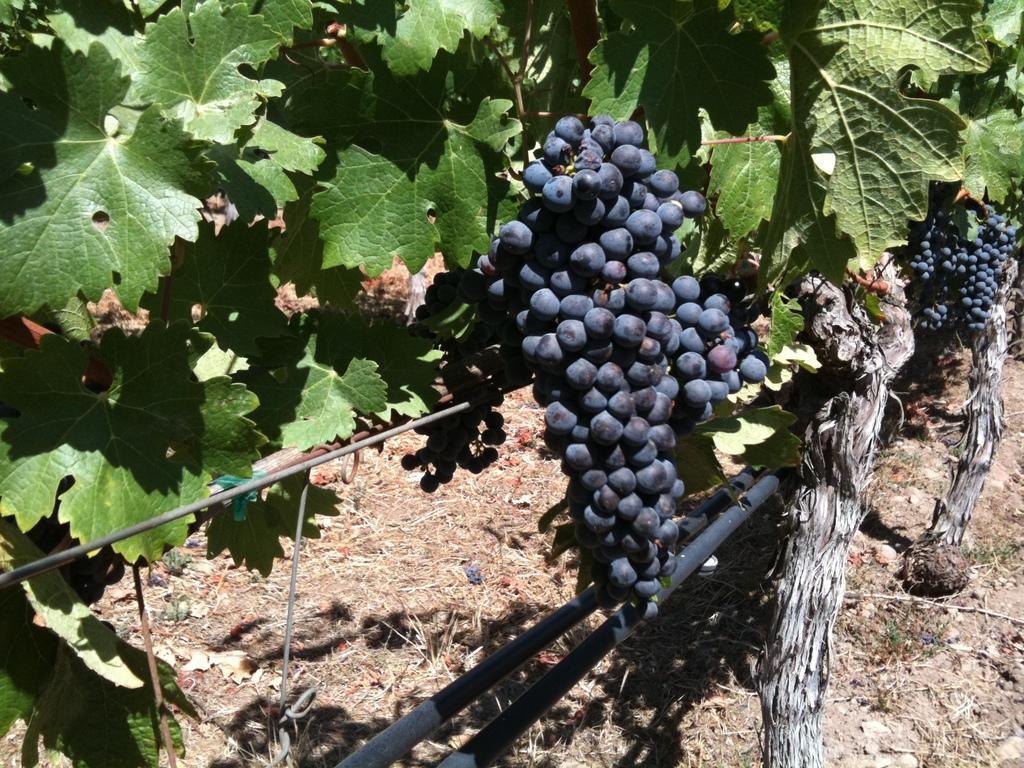In one or two sentences, can you explain what this image depicts? In this image we can see grapes and trees. 